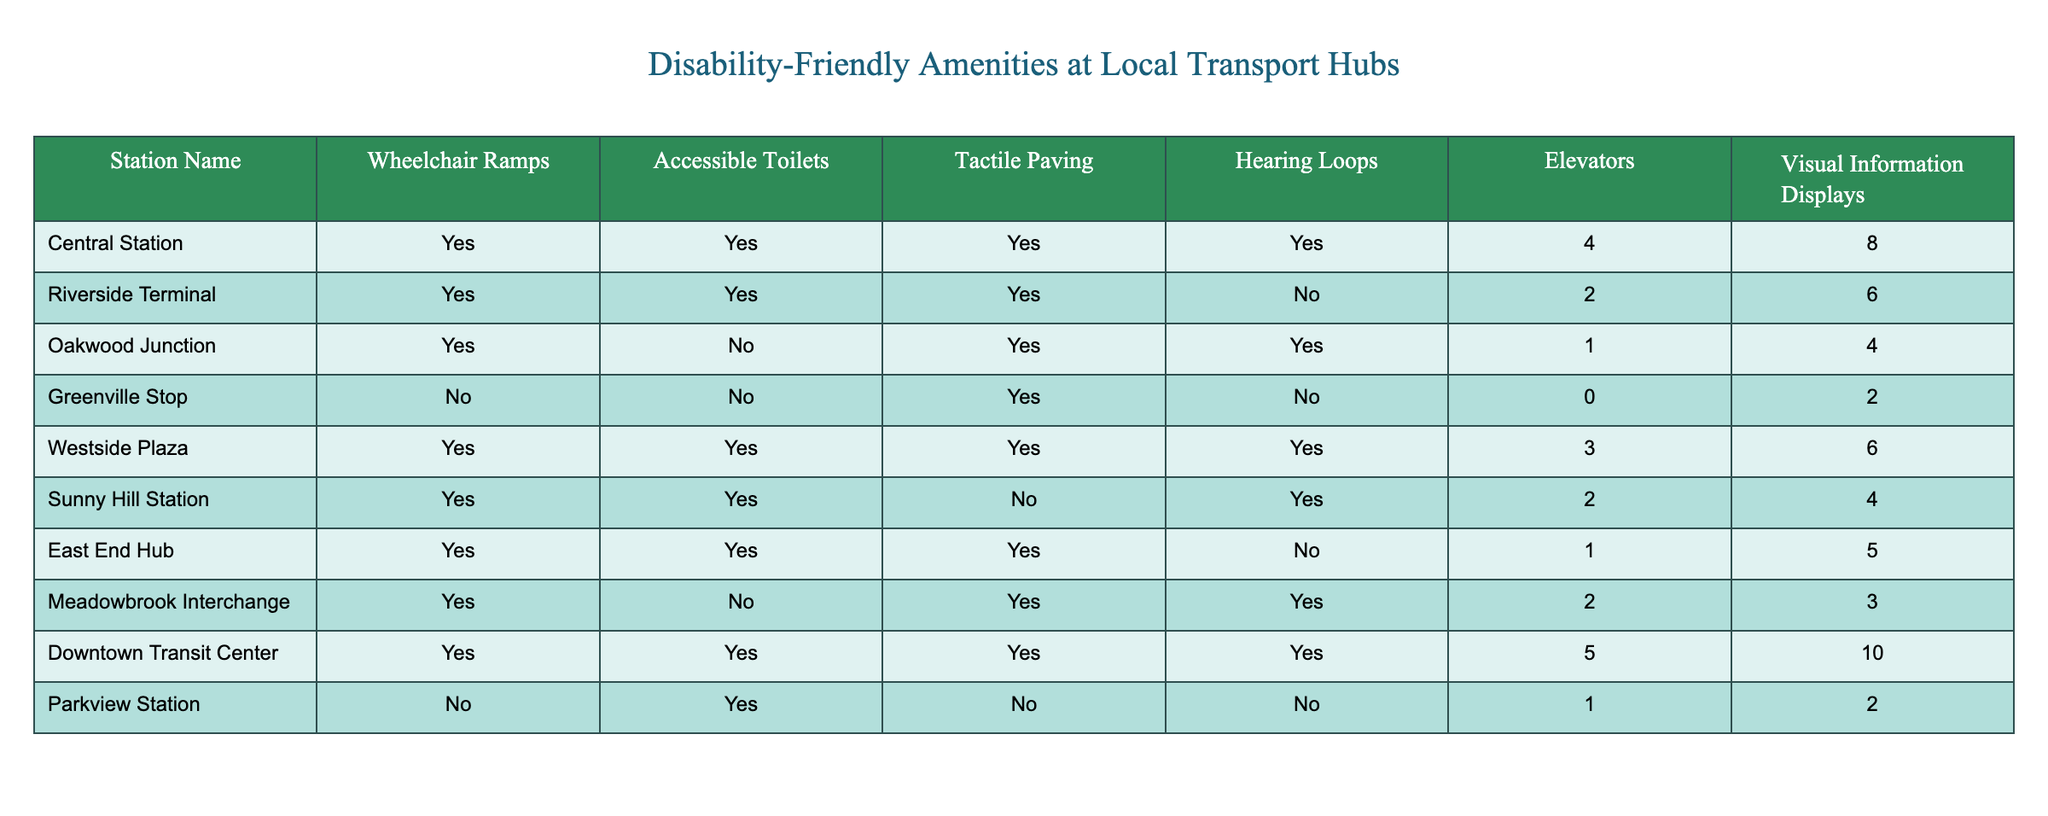What stations have wheelchair ramps? By scanning the "Wheelchair Ramps" column, I can identify which stations have been marked "Yes." The stations that meet this criterion are: Central Station, Riverside Terminal, Oakwood Junction, Westside Plaza, Sunny Hill Station, East End Hub, Meadowbrook Interchange, and Downtown Transit Center.
Answer: Central Station, Riverside Terminal, Oakwood Junction, Westside Plaza, Sunny Hill Station, East End Hub, Meadowbrook Interchange, Downtown Transit Center How many stations have accessible toilets? I will look at the "Accessible Toilets" column and count how many stations are marked "Yes." Upon checking, we find that there are 8 stations listed as having accessible toilets.
Answer: 8 Is there a station that has both tactile paving and elevators? By reviewing the "Tactile Paving" and "Elevators" columns, I find "Yes" values for both amenities. I check each station and find that Central Station, Riverside Terminal, Westside Plaza, and Downtown Transit Center meet both conditions.
Answer: Yes What is the total count of hearing loops available at all stations combined? I sum the values from the "Hearing Loops" column. The loop availability sums to: 4 + 0 + 1 + 0 + 3 + 2 + 0 + 2 + 5 + 0 = 17. Thus, the total number of hearing loops available is 17 across all stations.
Answer: 17 Which station has the most elevators? I will look at the "Elevators" column and find the highest number listed. Downtown Transit Center has the highest number of elevators at 5.
Answer: Downtown Transit Center Are there any stations without tactile paving? Checking for "No" values in the "Tactile Paving" column, I find that Greenville Stop and Parkview Station do not have tactile paving.
Answer: Yes What is the average number of visual information displays across the stations? To find the average, I will sum the numbers in the "Visual Information Displays" column (8 + 6 + 4 + 2 + 6 + 4 + 5 + 3 + 10 + 2 = 50) and divide by the number of stations (10). Thus, the average is 50 / 10 = 5.
Answer: 5 How many total stations have either accessible toilets or elevators? I need to analyze the "Accessible Toilets" and "Elevators" columns. The stations with accessible toilets are 8, and those with elevators are 6. However, some overlap exists: Central Station, Riverside Terminal, Westside Plaza, Sunny Hill Station, East End Hub, Meadowbrook Interchange, and Downtown Transit Center. Using a union method, I count distinct stations: 9 unique stations have either or both amenities.
Answer: 9 Which station offers the least number of wheelchair ramps? Searching the "Wheelchair Ramps" column, I see that Greenville Stop has "No" wheelchair ramps, which is the lowest when compared against other stations that all provide ramps.
Answer: Greenville Stop 